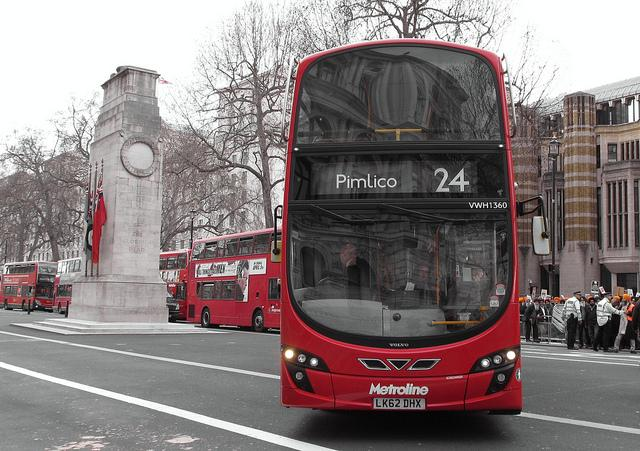Which bus company owns this bus? Please explain your reasoning. metroline. The front of the bus says metroline. 